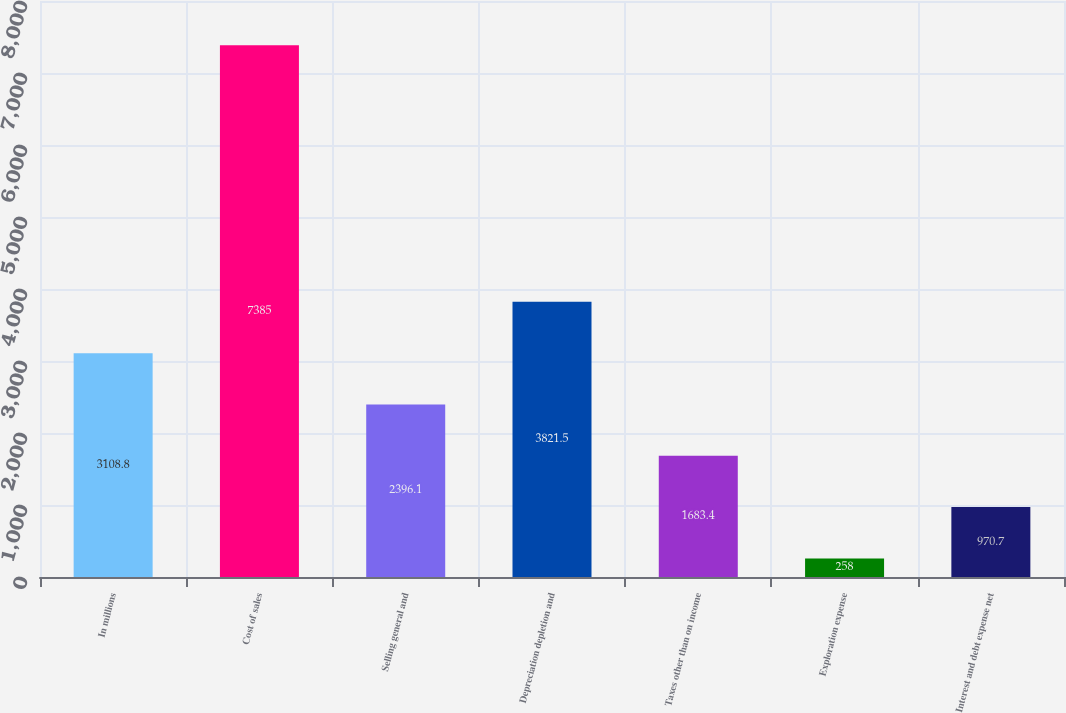Convert chart. <chart><loc_0><loc_0><loc_500><loc_500><bar_chart><fcel>In millions<fcel>Cost of sales<fcel>Selling general and<fcel>Depreciation depletion and<fcel>Taxes other than on income<fcel>Exploration expense<fcel>Interest and debt expense net<nl><fcel>3108.8<fcel>7385<fcel>2396.1<fcel>3821.5<fcel>1683.4<fcel>258<fcel>970.7<nl></chart> 